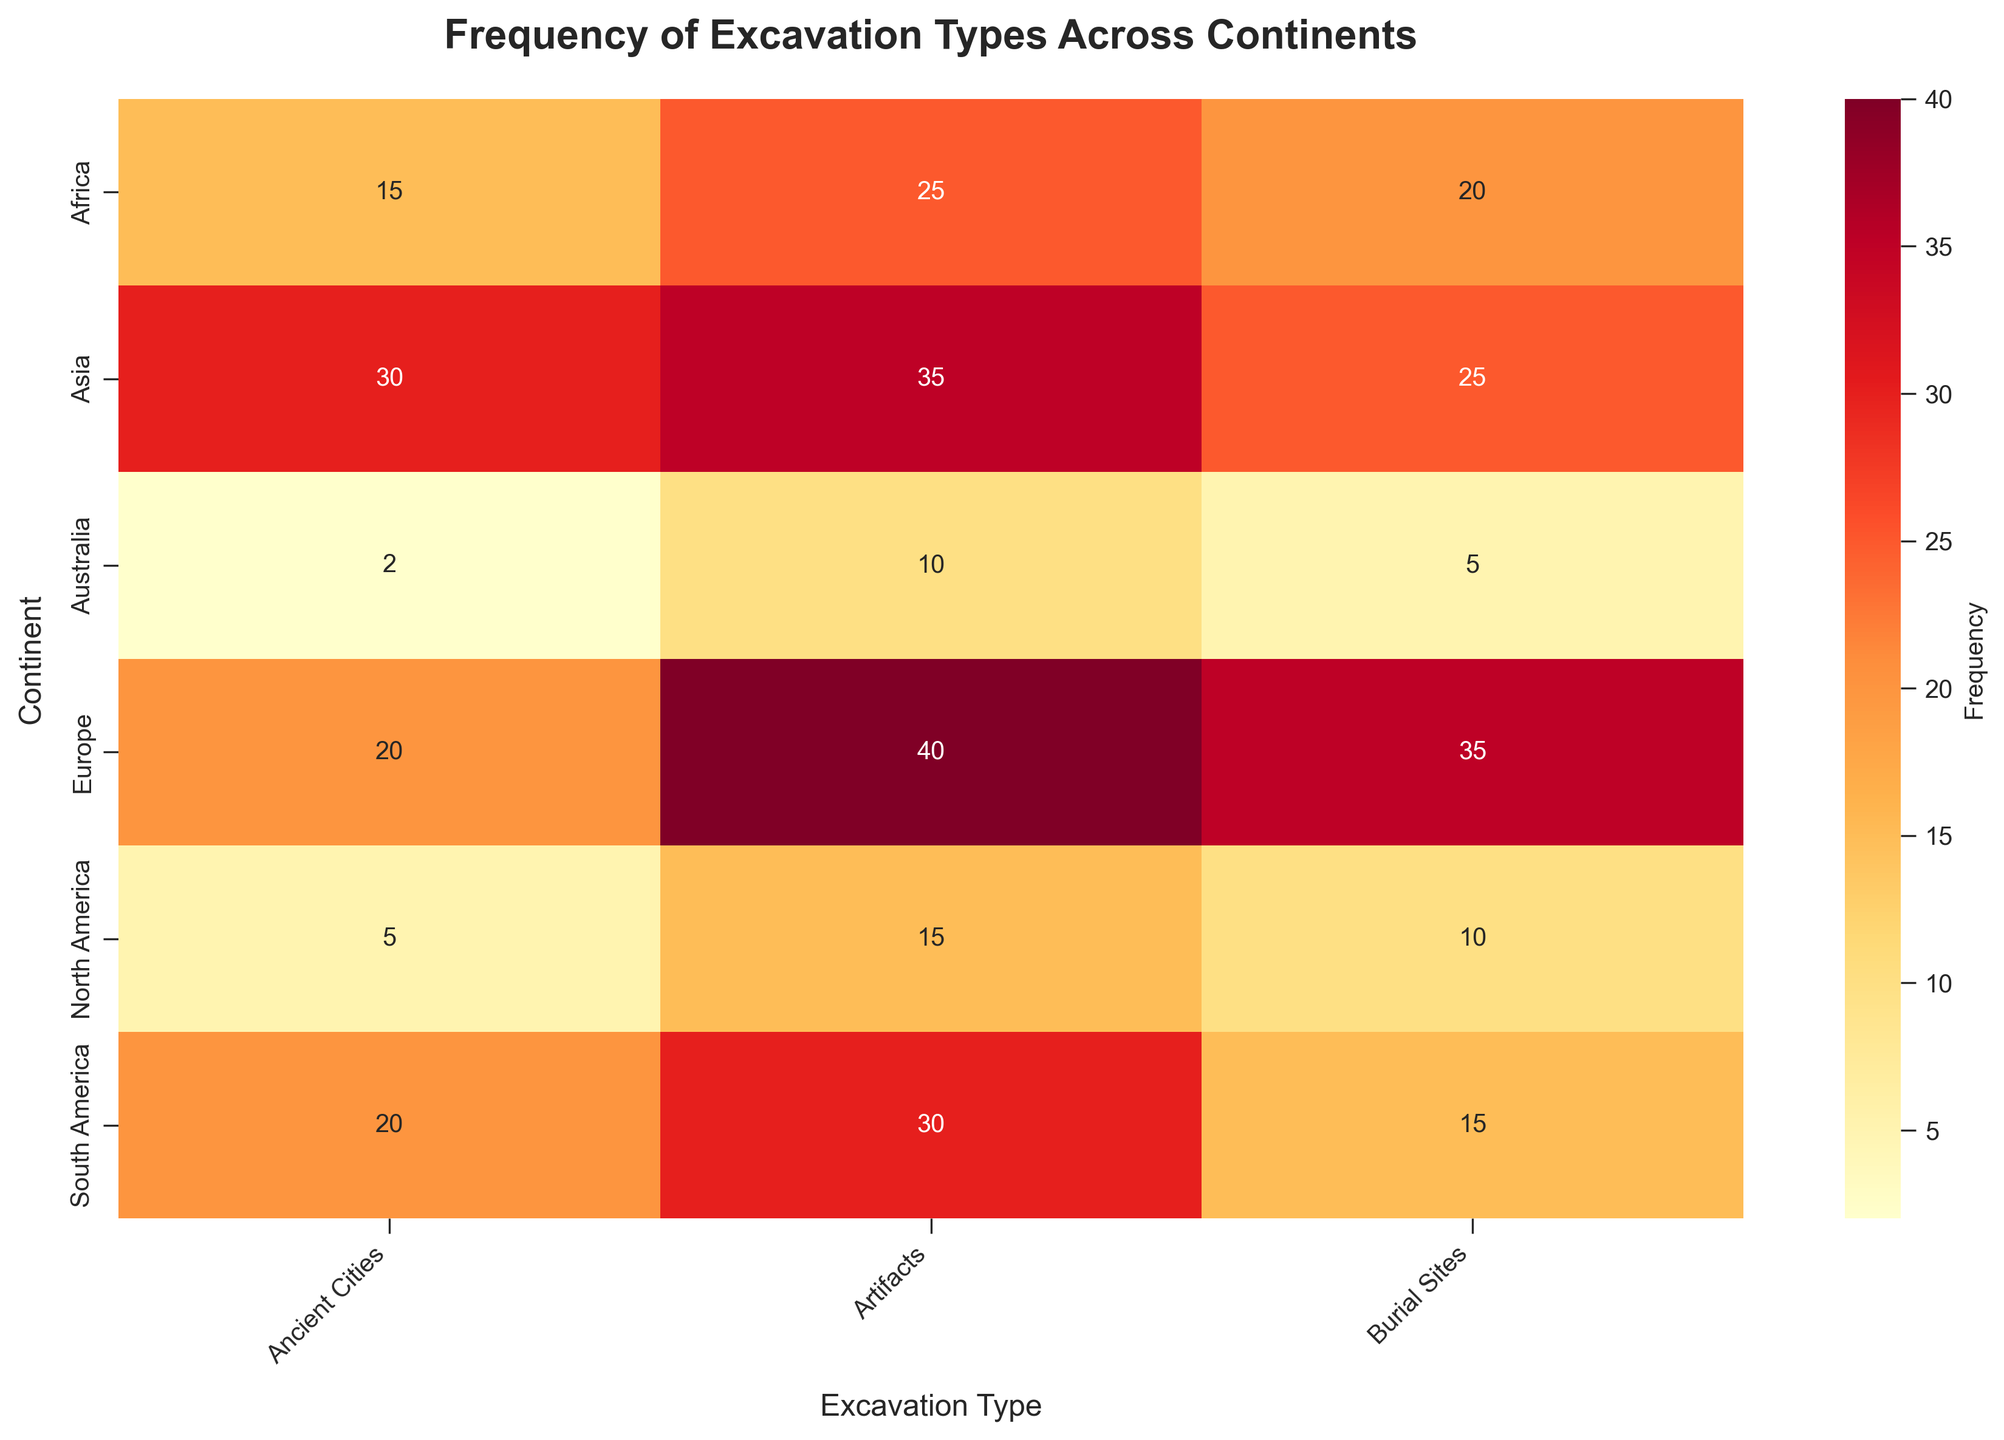what is the highest frequency excavation type in Europe? The heatmap shows three excavation types across different continents. For Europe, looking at the values at the intersection with Europe, the highest frequency is for artifacts with a frequency of 40.
Answer: Artifacts, 40 Which continent has the lowest frequency of excavation sites for burial sites? By examining the heatmap, searching for the lowest value among the different continents for burial sites which is 5. This is associated with Australia.
Answer: Australia, 5 What is the total number of excavation types listed for Asia? Adding the values of all excavation types for Asia: 25 (burial sites) + 30 (ancient cities) + 35 (artifacts) = 90.
Answer: 90 In which continent are ancient cities excavated more frequently than artifacts? By comparing the two frequencies for each continent. Asia, Africa, and South America are the continents shown. Only Asia has ancient cities (30) more frequent than artifacts (35).
Answer: None Which continent has the highest overall frequency of excavation types? Summing the frequencies of each excavation type for each continent, the highest total can be found. Europe: 95, Asia: 90, Africa: 60, North America: 30, South America: 65, Australia: 17. Europe has the highest total frequency.
Answer: Europe Which excavation type has the highest frequency in Africa? Analyzing the row corresponding to Africa, looking for the highest value. Here, artifacts have the highest frequency of 25.
Answer: Artifacts What is the difference in the frequency of burial sites between North America and South America? The heatmap shows 10 for North America and 15 for South America for burial sites. The difference is 15 - 10 = 5.
Answer: 5 Are there any excavation types that have the same frequency across all continents? By comparing the frequencies of each excavation type across all continents to see if any are the same. None of the excavation types have uniform frequencies across all continents.
Answer: No 